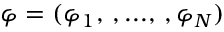Convert formula to latex. <formula><loc_0><loc_0><loc_500><loc_500>\varphi = ( \varphi _ { 1 } , \, , \dots , \, , \varphi _ { N } )</formula> 